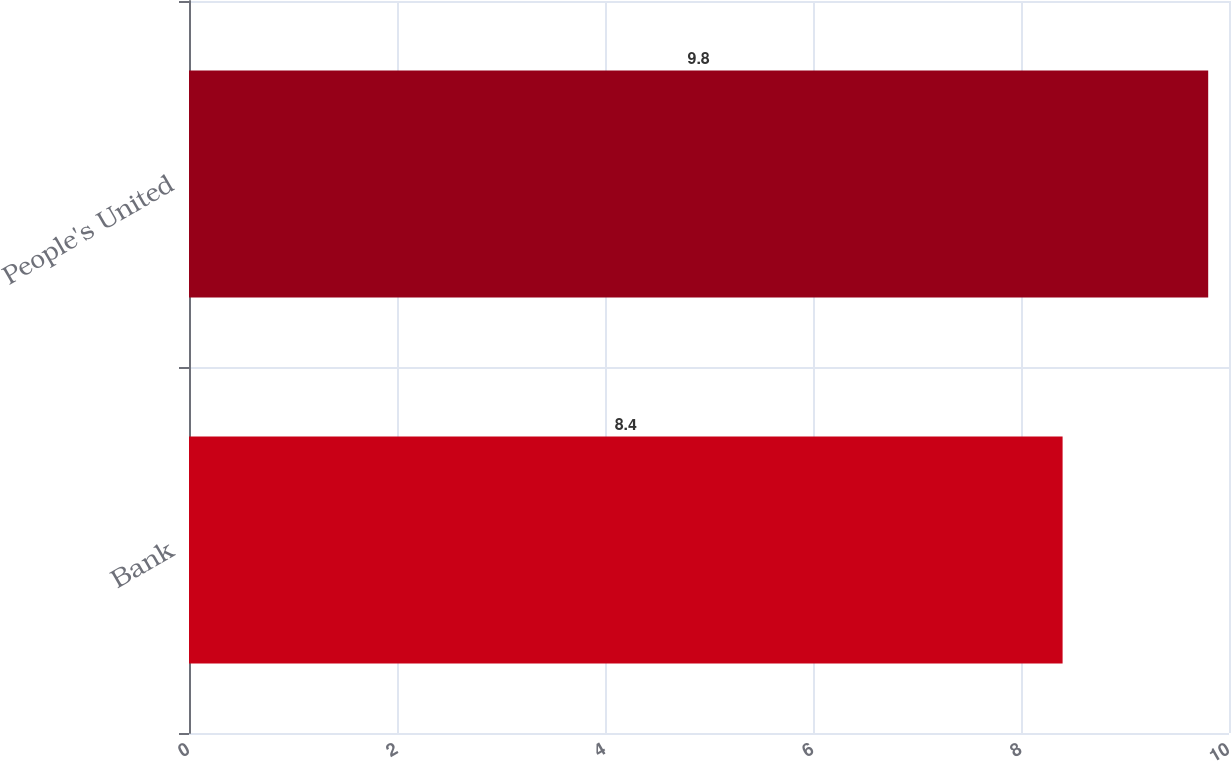Convert chart to OTSL. <chart><loc_0><loc_0><loc_500><loc_500><bar_chart><fcel>Bank<fcel>People's United<nl><fcel>8.4<fcel>9.8<nl></chart> 